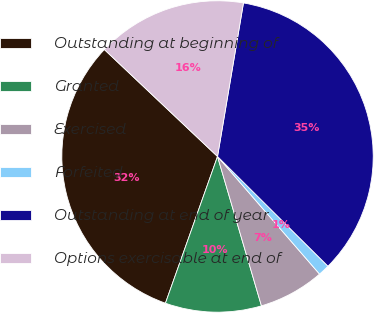Convert chart. <chart><loc_0><loc_0><loc_500><loc_500><pie_chart><fcel>Outstanding at beginning of<fcel>Granted<fcel>Exercised<fcel>Forfeited<fcel>Outstanding at end of year<fcel>Options exercisable at end of<nl><fcel>31.62%<fcel>9.98%<fcel>6.82%<fcel>1.18%<fcel>34.78%<fcel>15.61%<nl></chart> 